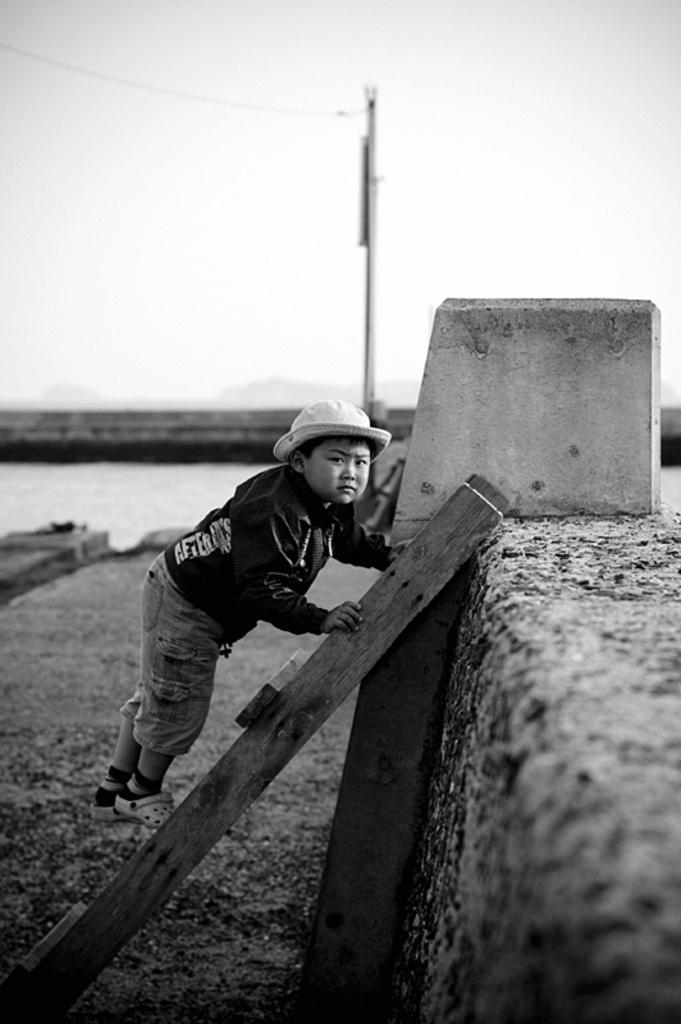Could you give a brief overview of what you see in this image? This is a black and white picture. In this picture, we see a boy is climbing the ladder. Behind that, we see a wall. In the background, we see an electric pole. We see water and this water might be in the canal. In the background, we see the sky. 